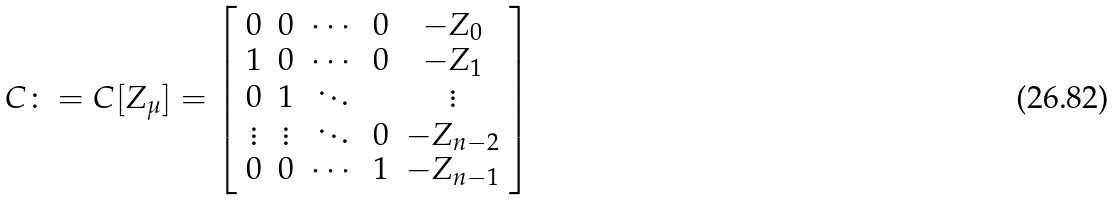<formula> <loc_0><loc_0><loc_500><loc_500>C \colon = C [ Z _ { \mu } ] = \left [ \begin{array} { c c c c c } 0 & 0 & \cdots & 0 & - Z _ { 0 } \\ 1 & 0 & \cdots & 0 & - Z _ { 1 } \\ 0 & 1 & \ddots & & \vdots \\ \vdots & \vdots & \ddots & 0 & - Z _ { n - 2 } \\ 0 & 0 & \cdots & 1 & - Z _ { n - 1 } \end{array} \right ]</formula> 